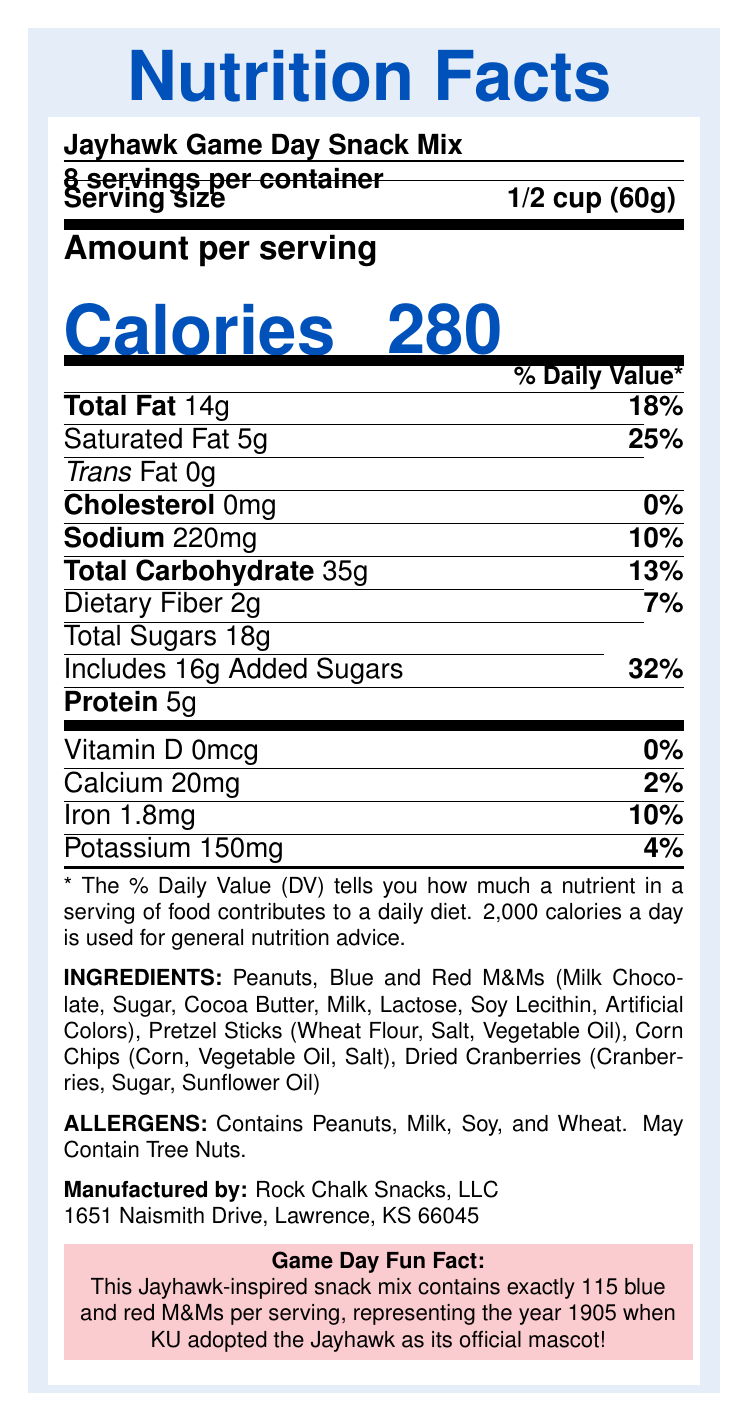what is the serving size of the Jayhawk Game Day Snack Mix? The serving size is explicitly mentioned in the Nutrition Facts Label.
Answer: 1/2 cup (60g) how many calories are there per serving? The document shows the calories per serving in large font: "Calories 280".
Answer: 280 how many servings are in the entire container? The label clearly states "8 servings per container".
Answer: 8 which nutrient has the highest daily value percentage? The daily value percentages are listed next to each nutrient, and Added Sugars have the highest at 32%.
Answer: Added Sugars what are the main ingredients in the snack mix? The ingredients are clearly listed under the "Ingredients" section.
Answer: Peanuts, Blue and Red M&Ms, Pretzel Sticks, Corn Chips, Dried Cranberries how much sodium does one serving contain? Sodium content per serving is listed in the Nutrition Facts Label.
Answer: 220mg what percentage of the daily value of calcium does one serving provide? The calcium daily value percentage is mentioned in the label.
Answer: 2% how much protein is there in a single serving? Protein content per serving is found in the Nutrition Facts section.
Answer: 5g how many grams of sugars are added? It says "Includes 16g Added Sugars" in the Nutrition Facts.
Answer: 16g which allergen listed might not be in the snack mix? A. Peanuts B. Soy C. Tree Nuts The allergen section mentions "May Contain Tree Nuts", indicating it's a possibility but not definite.
Answer: C. Tree Nuts how much iron is there per serving? A. 1.0mg B. 1.8mg C. 2.0mg D. 10mg Iron content per serving is specified as 1.8mg.
Answer: B. 1.8mg which of the following ingredients is not in the snack mix? I. Pretzel Sticks II. Blue and Red M&Ms III. Almonds IV. Corn Chips Almonds are not listed in the ingredients.
Answer: III. Almonds is there any cholesterol in the snack mix? The label lists cholesterol as 0mg, indicating there is none.
Answer: No summarize the main details provided in the document The document provides a comprehensive overview of the nutritional content, ingredients, allergens, and some extra information about the product.
Answer: The Nutrition Facts Label for Jayhawk Game Day Snack Mix indicates a serving size of 1/2 cup (60g) with 280 calories. There are 8 servings per container. The main ingredients include Peanuts, Blue and Red M&Ms, Pretzel Sticks, Corn Chips, and Dried Cranberries. Nutritional details such as fat, sodium, and sugars are provided along with % daily values. Allergen information and a fun fact about the M&Ms are also included. what is the total carbohydrate content per container? The document provides only the carbohydrate content per serving, not the total per container.
Answer: Cannot be determined 